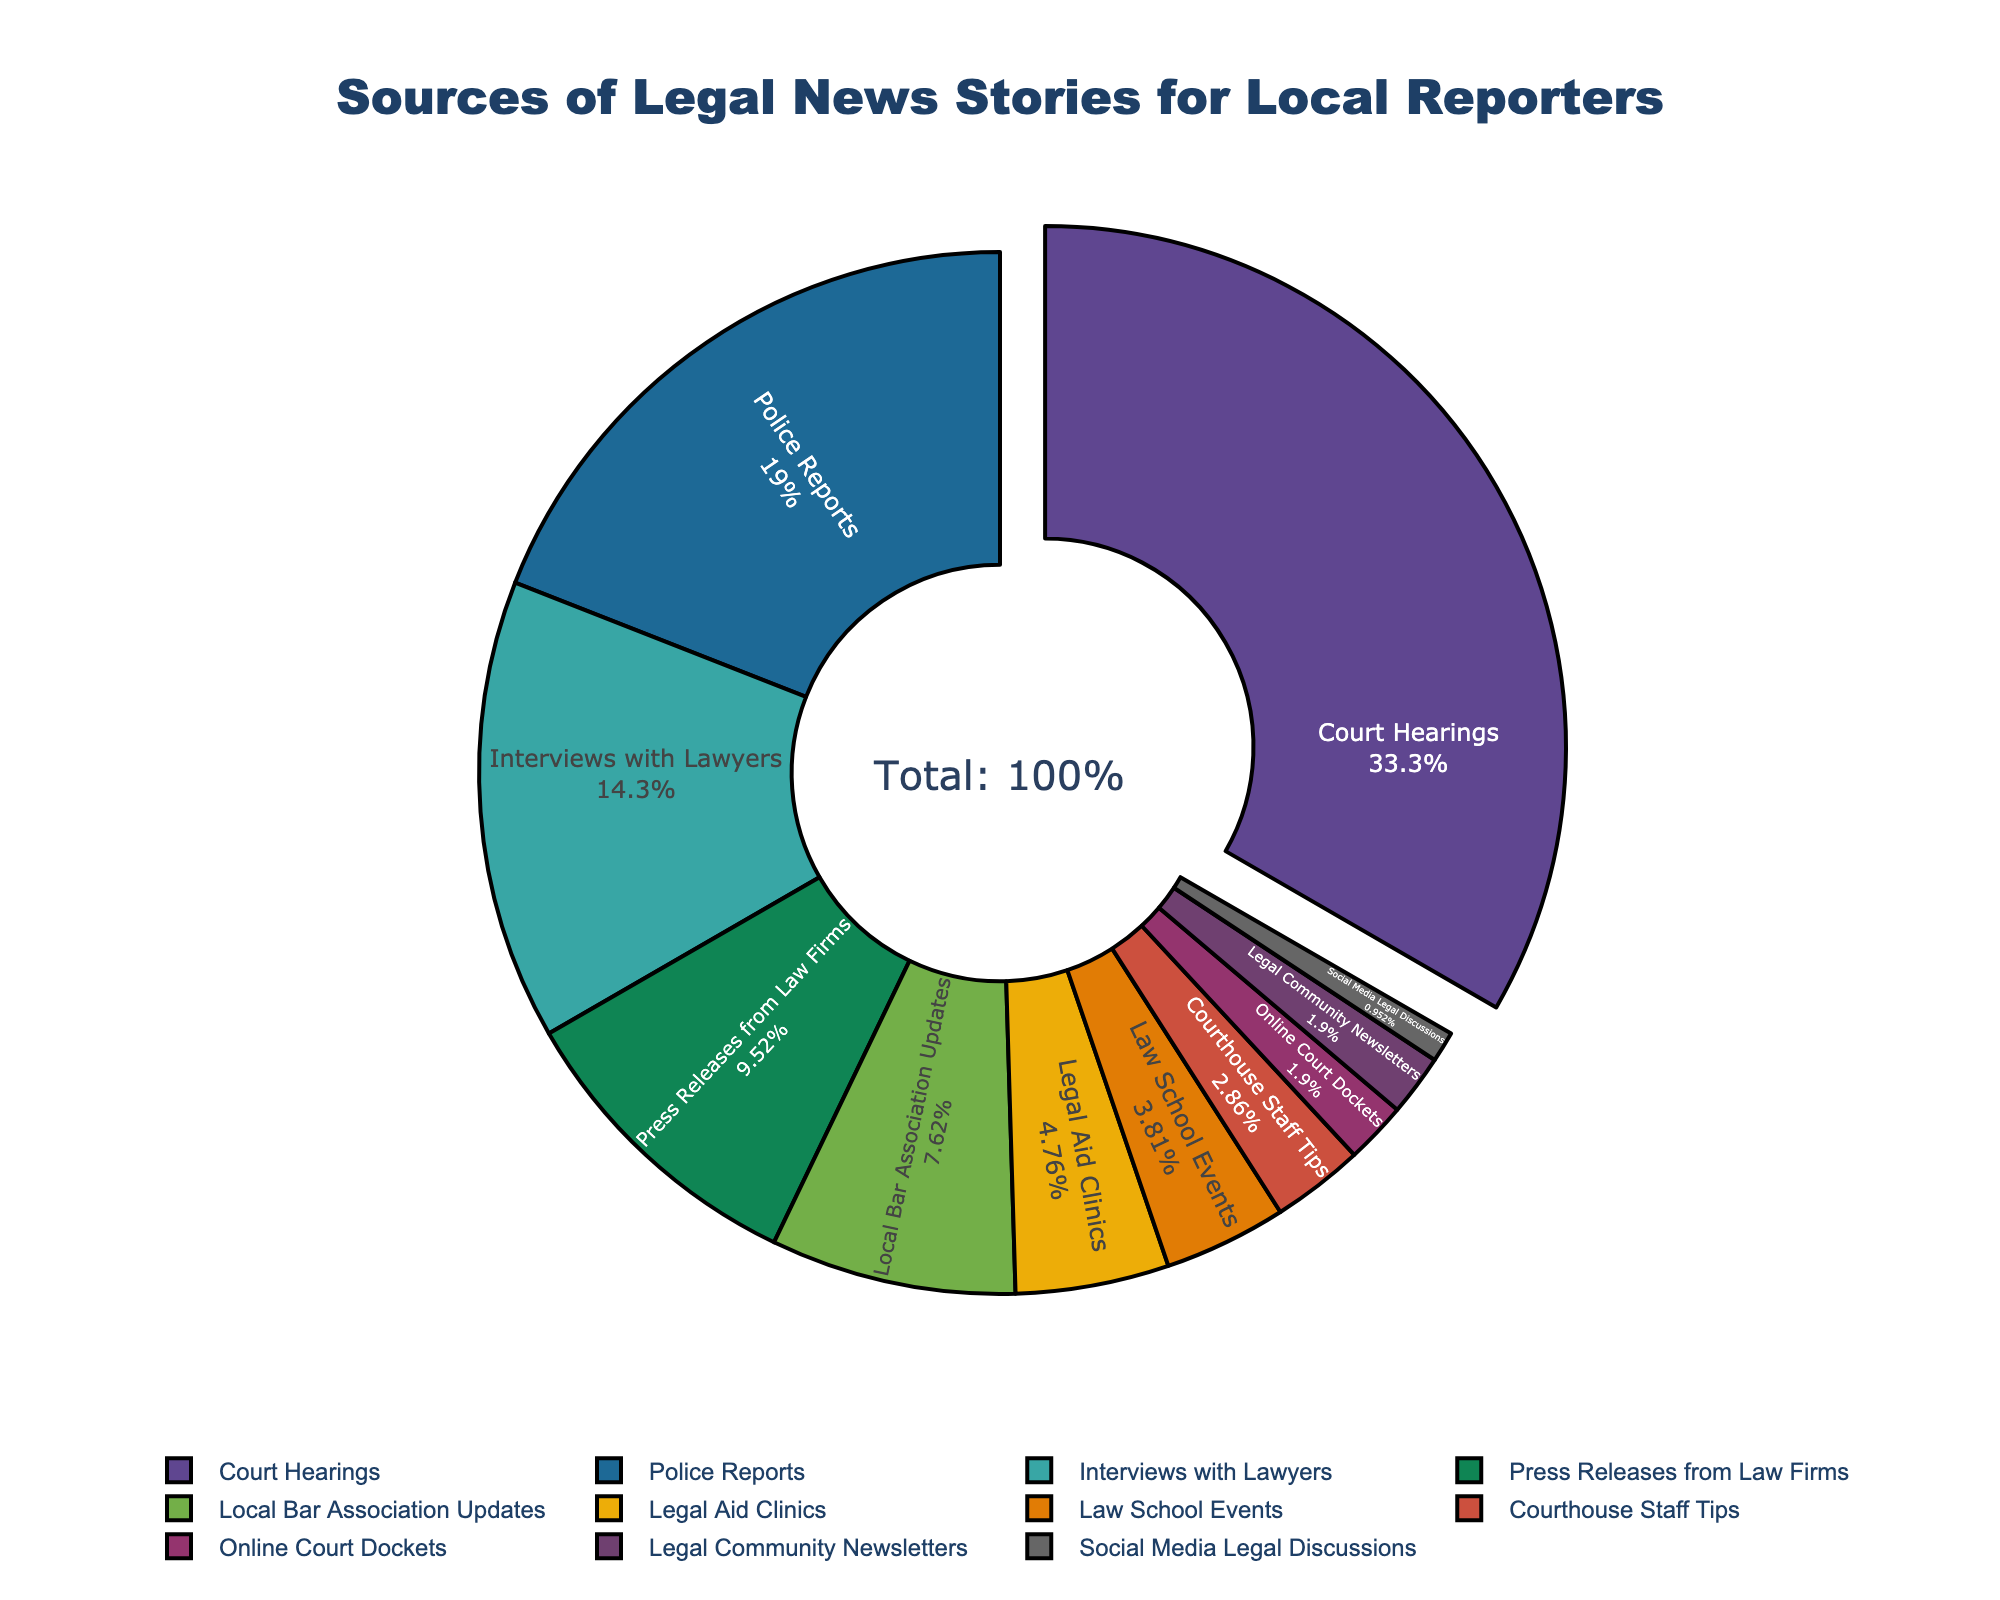What is the largest source of legal news stories for local reporters? The figure shows a donut chart with various sources of legal news stories. The segment with the largest percentage will be the largest source. In this case, "Court Hearings" has the largest segment.
Answer: Court Hearings How much more news does "Court Hearings" provide compared to "Police Reports"? "Court Hearings" provides 35% of the news, while "Police Reports" provide 20%. The difference is calculated as 35% - 20%.
Answer: 15% If you combine the percentages of "Legal Aid Clinics," "Law School Events," and "Courthouse Staff Tips," what is their total percentage? The percentages are 5% for Legal Aid Clinics, 4% for Law School Events, and 3% for Courthouse Staff Tips. Summing these up, 5% + 4% + 3%.
Answer: 12% Which source provides less news than "Local Bar Association Updates" but more than "Social Media Legal Discussions"? The figure shows "Local Bar Association Updates" at 8% and "Social Media Legal Discussions" at 1%. The source between these values is "Legal Aid Clinics" at 5%.
Answer: Legal Aid Clinics Are "Online Court Dockets" and "Legal Community Newsletters" equal in their percentage contributions? The chart shows both "Online Court Dockets" and "Legal Community Newsletters" contributing 2% each.
Answer: Yes What percentage of news stories come from online sources ("Online Court Dockets" and "Social Media Legal Discussions") combined? "Online Court Dockets" contribute 2% and "Social Media Legal Discussions" contribute 1%. Their combined percentage is 2% + 1%.
Answer: 3% Which visual element shows the source with the smallest contribution, and what is it? The smallest segment in the donut chart has a percentage shown within it and is labeled. The label "Social Media Legal Discussions" and its segment are the smallest.
Answer: Social Media Legal Discussions If you wanted to reduce reliance on the top three sources by 10% each, what would their new percentages be? The top three sources are "Court Hearings" at 35%, "Police Reports" at 20%, and "Interviews with Lawyers" at 15%. Reducing each by 10%, the new percentages would be 35% - 10%, 20% - 10%, and 15% - 10%.
Answer: 25%, 10%, 5% Which source falls exactly between 5% and 10% in its contribution? The source within this range is "Press Releases from Law Firms," contributing 10%.
Answer: Press Releases from Law Firms What percentage of news is sourced from "Interviews with Lawyers" and "Press Releases from Law Firms" together? "Interviews with Lawyers" provide 15% and "Press Releases from Law Firms" provide 10%. Combining these gives 15% + 10%.
Answer: 25% 